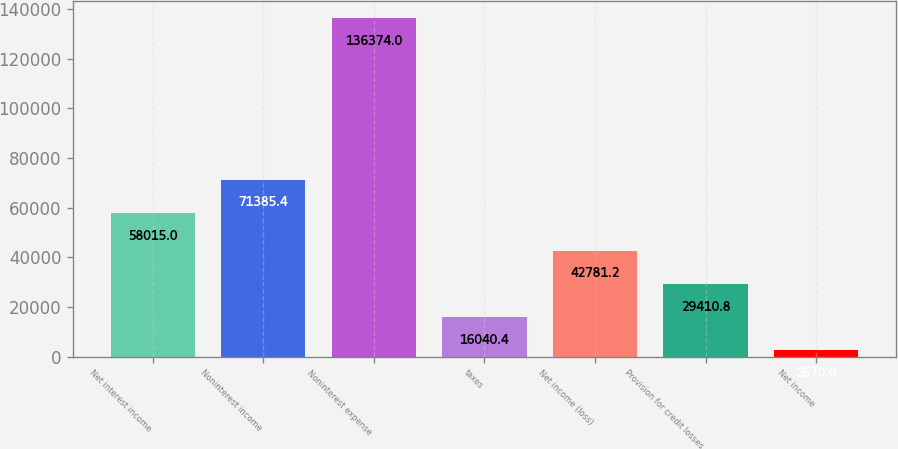Convert chart. <chart><loc_0><loc_0><loc_500><loc_500><bar_chart><fcel>Net interest income<fcel>Noninterest income<fcel>Noninterest expense<fcel>taxes<fcel>Net income (loss)<fcel>Provision for credit losses<fcel>Net income<nl><fcel>58015<fcel>71385.4<fcel>136374<fcel>16040.4<fcel>42781.2<fcel>29410.8<fcel>2670<nl></chart> 